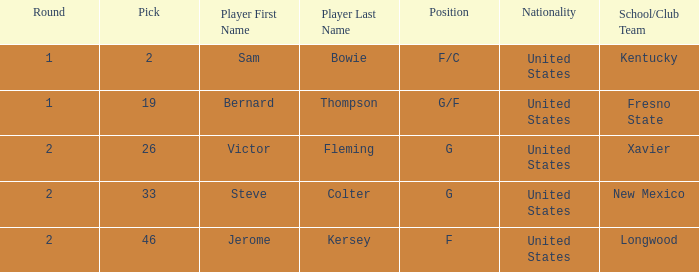What is Player, when Round is "2", and when School/Club Team is "Xavier"? Victor Fleming. 